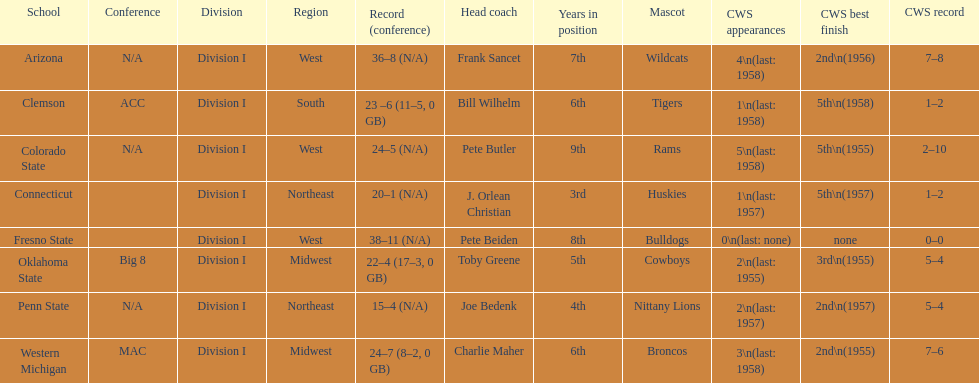List the schools that came in last place in the cws best finish. Clemson, Colorado State, Connecticut. 